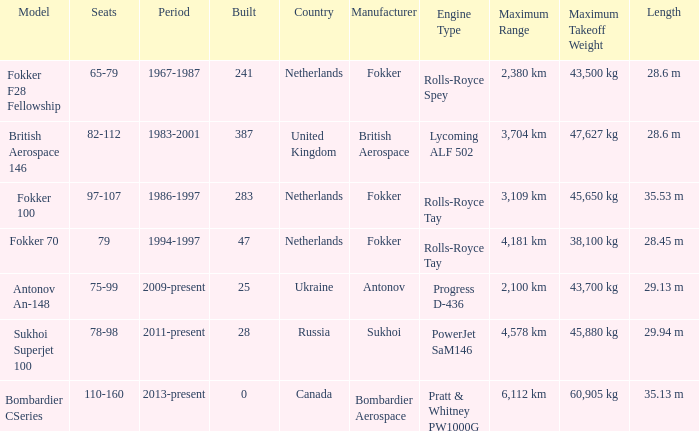I'm looking to parse the entire table for insights. Could you assist me with that? {'header': ['Model', 'Seats', 'Period', 'Built', 'Country', 'Manufacturer', 'Engine Type', 'Maximum Range', 'Maximum Takeoff Weight', 'Length'], 'rows': [['Fokker F28 Fellowship', '65-79', '1967-1987', '241', 'Netherlands', 'Fokker', 'Rolls-Royce Spey', '2,380 km', '43,500 kg', '28.6 m'], ['British Aerospace 146', '82-112', '1983-2001', '387', 'United Kingdom', 'British Aerospace', 'Lycoming ALF 502', '3,704 km', '47,627 kg', '28.6 m'], ['Fokker 100', '97-107', '1986-1997', '283', 'Netherlands', 'Fokker', 'Rolls-Royce Tay', '3,109 km', '45,650 kg', '35.53 m'], ['Fokker 70', '79', '1994-1997', '47', 'Netherlands', 'Fokker', 'Rolls-Royce Tay', '4,181 km', '38,100 kg', '28.45 m'], ['Antonov An-148', '75-99', '2009-present', '25', 'Ukraine', 'Antonov', 'Progress D-436', '2,100 km', '43,700 kg', '29.13 m'], ['Sukhoi Superjet 100', '78-98', '2011-present', '28', 'Russia', 'Sukhoi', 'PowerJet SaM146', '4,578 km', '45,880 kg', '29.94 m'], ['Bombardier CSeries', '110-160', '2013-present', '0', 'Canada', 'Bombardier Aerospace', 'Pratt & Whitney PW1000G', '6,112 km', '60,905 kg', '35.13 m']]} Between which years were there 241 fokker 70 model cabins built? 1994-1997. 